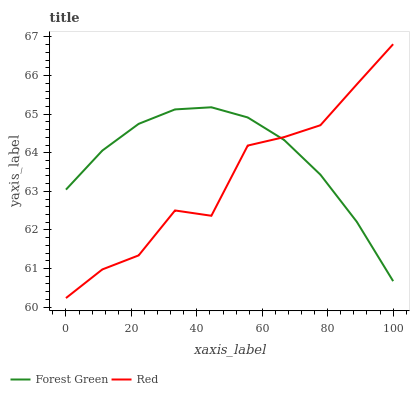Does Red have the maximum area under the curve?
Answer yes or no. No. Is Red the smoothest?
Answer yes or no. No. 